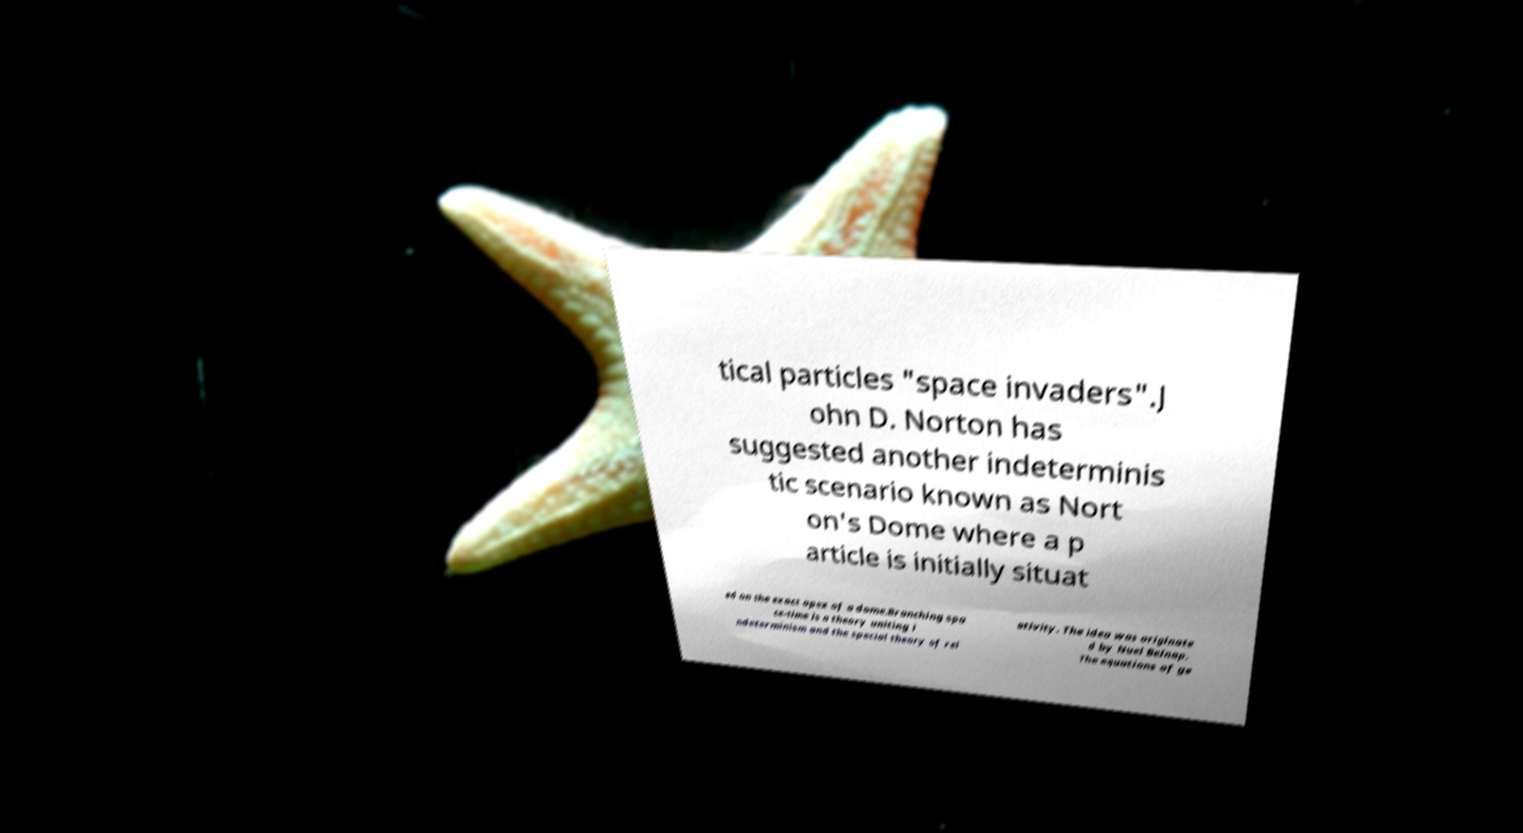For documentation purposes, I need the text within this image transcribed. Could you provide that? tical particles "space invaders".J ohn D. Norton has suggested another indeterminis tic scenario known as Nort on's Dome where a p article is initially situat ed on the exact apex of a dome.Branching spa ce-time is a theory uniting i ndeterminism and the special theory of rel ativity. The idea was originate d by Nuel Belnap. The equations of ge 